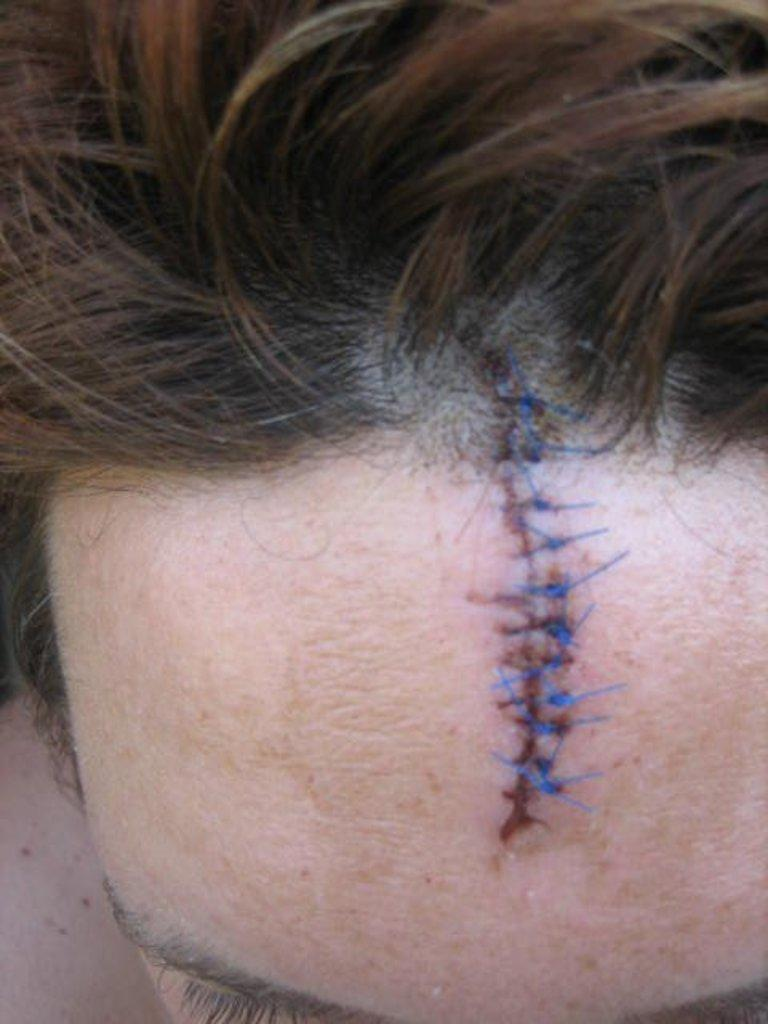What is present in the image? There is a person in the image. Which part of the person's face is visible in the image? The person's forehead is visible in the image. What else can be seen about the person in the image? The person's hair is visible in the image. What type of street is the person offering to manage in the image? There is no mention of a street or any offer in the image. 